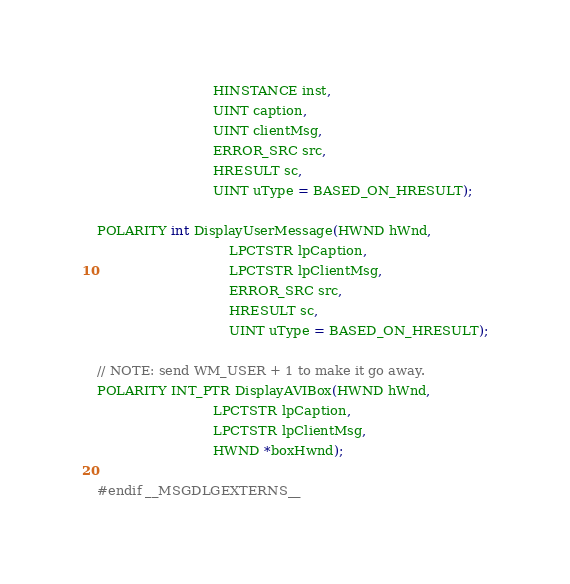<code> <loc_0><loc_0><loc_500><loc_500><_C_>							HINSTANCE inst,
							UINT caption, 
							UINT clientMsg, 
							ERROR_SRC src,
							HRESULT sc, 
							UINT uType = BASED_ON_HRESULT);

POLARITY int DisplayUserMessage(HWND hWnd,
								LPCTSTR lpCaption,
								LPCTSTR lpClientMsg,
								ERROR_SRC src,
								HRESULT sc,
								UINT uType = BASED_ON_HRESULT);

// NOTE: send WM_USER + 1 to make it go away.
POLARITY INT_PTR DisplayAVIBox(HWND hWnd,
							LPCTSTR lpCaption,
							LPCTSTR lpClientMsg,
							HWND *boxHwnd);

#endif __MSGDLGEXTERNS__
</code> 